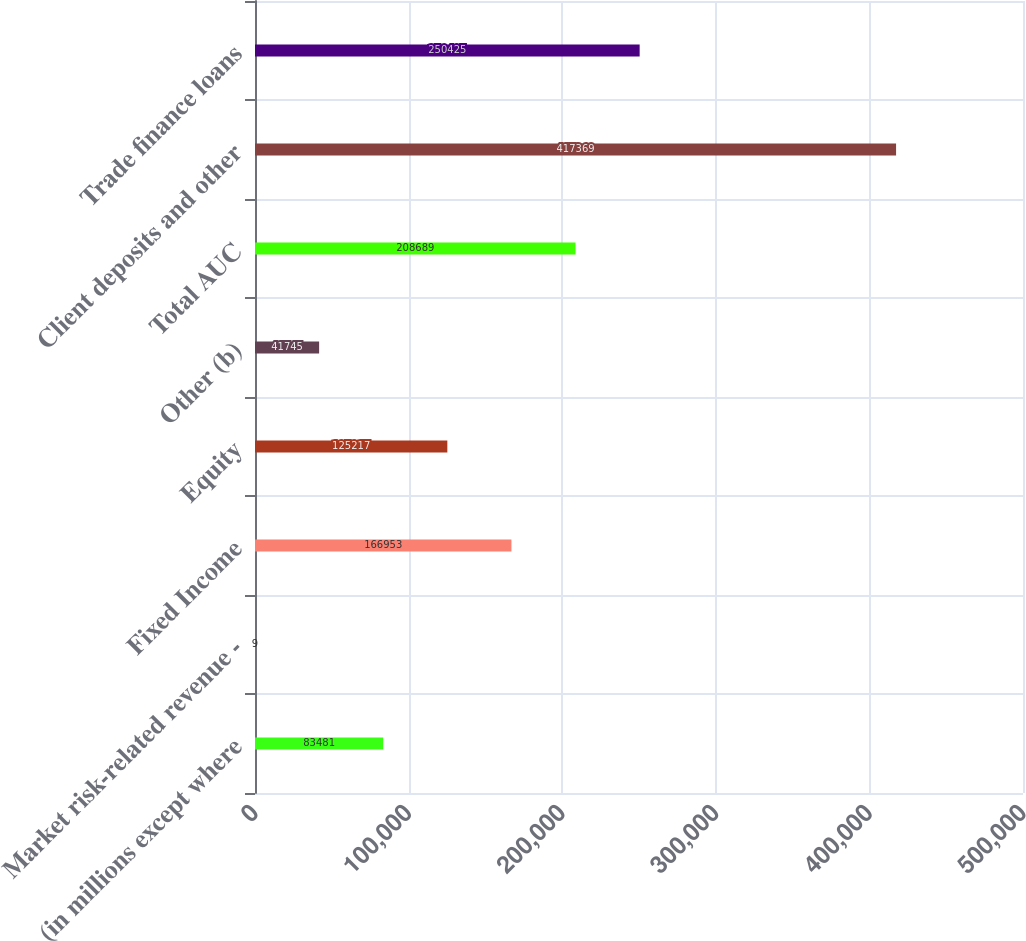Convert chart. <chart><loc_0><loc_0><loc_500><loc_500><bar_chart><fcel>(in millions except where<fcel>Market risk-related revenue -<fcel>Fixed Income<fcel>Equity<fcel>Other (b)<fcel>Total AUC<fcel>Client deposits and other<fcel>Trade finance loans<nl><fcel>83481<fcel>9<fcel>166953<fcel>125217<fcel>41745<fcel>208689<fcel>417369<fcel>250425<nl></chart> 